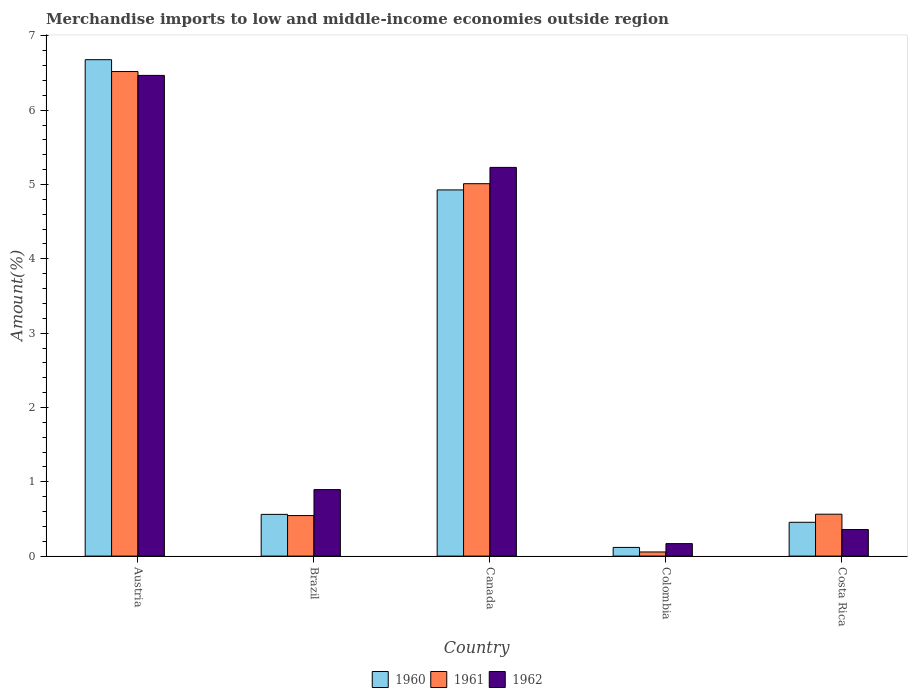How many different coloured bars are there?
Your answer should be very brief. 3. How many groups of bars are there?
Keep it short and to the point. 5. Are the number of bars per tick equal to the number of legend labels?
Provide a succinct answer. Yes. Are the number of bars on each tick of the X-axis equal?
Make the answer very short. Yes. How many bars are there on the 4th tick from the right?
Provide a succinct answer. 3. What is the percentage of amount earned from merchandise imports in 1960 in Costa Rica?
Give a very brief answer. 0.45. Across all countries, what is the maximum percentage of amount earned from merchandise imports in 1962?
Offer a terse response. 6.47. Across all countries, what is the minimum percentage of amount earned from merchandise imports in 1960?
Provide a short and direct response. 0.12. In which country was the percentage of amount earned from merchandise imports in 1962 maximum?
Offer a very short reply. Austria. What is the total percentage of amount earned from merchandise imports in 1961 in the graph?
Provide a short and direct response. 12.7. What is the difference between the percentage of amount earned from merchandise imports in 1962 in Brazil and that in Costa Rica?
Your response must be concise. 0.54. What is the difference between the percentage of amount earned from merchandise imports in 1960 in Colombia and the percentage of amount earned from merchandise imports in 1961 in Austria?
Make the answer very short. -6.4. What is the average percentage of amount earned from merchandise imports in 1960 per country?
Provide a succinct answer. 2.55. What is the difference between the percentage of amount earned from merchandise imports of/in 1961 and percentage of amount earned from merchandise imports of/in 1960 in Costa Rica?
Your response must be concise. 0.11. What is the ratio of the percentage of amount earned from merchandise imports in 1962 in Brazil to that in Costa Rica?
Ensure brevity in your answer.  2.5. What is the difference between the highest and the second highest percentage of amount earned from merchandise imports in 1960?
Provide a succinct answer. -4.37. What is the difference between the highest and the lowest percentage of amount earned from merchandise imports in 1962?
Keep it short and to the point. 6.3. In how many countries, is the percentage of amount earned from merchandise imports in 1960 greater than the average percentage of amount earned from merchandise imports in 1960 taken over all countries?
Your response must be concise. 2. Is the sum of the percentage of amount earned from merchandise imports in 1962 in Brazil and Colombia greater than the maximum percentage of amount earned from merchandise imports in 1961 across all countries?
Ensure brevity in your answer.  No. What does the 3rd bar from the left in Austria represents?
Provide a short and direct response. 1962. What does the 3rd bar from the right in Brazil represents?
Keep it short and to the point. 1960. How many bars are there?
Your response must be concise. 15. How many countries are there in the graph?
Provide a short and direct response. 5. Are the values on the major ticks of Y-axis written in scientific E-notation?
Give a very brief answer. No. Does the graph contain any zero values?
Keep it short and to the point. No. What is the title of the graph?
Your response must be concise. Merchandise imports to low and middle-income economies outside region. Does "2010" appear as one of the legend labels in the graph?
Give a very brief answer. No. What is the label or title of the X-axis?
Ensure brevity in your answer.  Country. What is the label or title of the Y-axis?
Offer a very short reply. Amount(%). What is the Amount(%) in 1960 in Austria?
Offer a very short reply. 6.68. What is the Amount(%) of 1961 in Austria?
Your answer should be compact. 6.52. What is the Amount(%) of 1962 in Austria?
Your response must be concise. 6.47. What is the Amount(%) in 1960 in Brazil?
Make the answer very short. 0.56. What is the Amount(%) of 1961 in Brazil?
Ensure brevity in your answer.  0.55. What is the Amount(%) of 1962 in Brazil?
Give a very brief answer. 0.89. What is the Amount(%) in 1960 in Canada?
Keep it short and to the point. 4.93. What is the Amount(%) in 1961 in Canada?
Offer a terse response. 5.01. What is the Amount(%) of 1962 in Canada?
Your response must be concise. 5.23. What is the Amount(%) in 1960 in Colombia?
Give a very brief answer. 0.12. What is the Amount(%) in 1961 in Colombia?
Ensure brevity in your answer.  0.06. What is the Amount(%) in 1962 in Colombia?
Keep it short and to the point. 0.17. What is the Amount(%) of 1960 in Costa Rica?
Make the answer very short. 0.45. What is the Amount(%) in 1961 in Costa Rica?
Provide a short and direct response. 0.56. What is the Amount(%) of 1962 in Costa Rica?
Your answer should be compact. 0.36. Across all countries, what is the maximum Amount(%) in 1960?
Provide a succinct answer. 6.68. Across all countries, what is the maximum Amount(%) in 1961?
Your answer should be very brief. 6.52. Across all countries, what is the maximum Amount(%) in 1962?
Provide a short and direct response. 6.47. Across all countries, what is the minimum Amount(%) of 1960?
Give a very brief answer. 0.12. Across all countries, what is the minimum Amount(%) in 1961?
Ensure brevity in your answer.  0.06. Across all countries, what is the minimum Amount(%) of 1962?
Provide a short and direct response. 0.17. What is the total Amount(%) of 1960 in the graph?
Offer a very short reply. 12.74. What is the total Amount(%) in 1961 in the graph?
Offer a terse response. 12.7. What is the total Amount(%) in 1962 in the graph?
Provide a short and direct response. 13.12. What is the difference between the Amount(%) of 1960 in Austria and that in Brazil?
Your response must be concise. 6.12. What is the difference between the Amount(%) in 1961 in Austria and that in Brazil?
Your response must be concise. 5.97. What is the difference between the Amount(%) in 1962 in Austria and that in Brazil?
Your answer should be very brief. 5.57. What is the difference between the Amount(%) of 1960 in Austria and that in Canada?
Provide a short and direct response. 1.75. What is the difference between the Amount(%) of 1961 in Austria and that in Canada?
Give a very brief answer. 1.51. What is the difference between the Amount(%) of 1962 in Austria and that in Canada?
Make the answer very short. 1.24. What is the difference between the Amount(%) in 1960 in Austria and that in Colombia?
Offer a very short reply. 6.56. What is the difference between the Amount(%) in 1961 in Austria and that in Colombia?
Ensure brevity in your answer.  6.46. What is the difference between the Amount(%) in 1962 in Austria and that in Colombia?
Keep it short and to the point. 6.3. What is the difference between the Amount(%) of 1960 in Austria and that in Costa Rica?
Provide a short and direct response. 6.22. What is the difference between the Amount(%) in 1961 in Austria and that in Costa Rica?
Provide a succinct answer. 5.96. What is the difference between the Amount(%) of 1962 in Austria and that in Costa Rica?
Offer a terse response. 6.11. What is the difference between the Amount(%) in 1960 in Brazil and that in Canada?
Your response must be concise. -4.37. What is the difference between the Amount(%) in 1961 in Brazil and that in Canada?
Offer a terse response. -4.47. What is the difference between the Amount(%) of 1962 in Brazil and that in Canada?
Ensure brevity in your answer.  -4.34. What is the difference between the Amount(%) in 1960 in Brazil and that in Colombia?
Ensure brevity in your answer.  0.44. What is the difference between the Amount(%) in 1961 in Brazil and that in Colombia?
Provide a succinct answer. 0.49. What is the difference between the Amount(%) in 1962 in Brazil and that in Colombia?
Ensure brevity in your answer.  0.73. What is the difference between the Amount(%) of 1960 in Brazil and that in Costa Rica?
Your answer should be very brief. 0.11. What is the difference between the Amount(%) of 1961 in Brazil and that in Costa Rica?
Your answer should be compact. -0.02. What is the difference between the Amount(%) of 1962 in Brazil and that in Costa Rica?
Make the answer very short. 0.54. What is the difference between the Amount(%) of 1960 in Canada and that in Colombia?
Provide a succinct answer. 4.81. What is the difference between the Amount(%) in 1961 in Canada and that in Colombia?
Make the answer very short. 4.96. What is the difference between the Amount(%) in 1962 in Canada and that in Colombia?
Make the answer very short. 5.06. What is the difference between the Amount(%) in 1960 in Canada and that in Costa Rica?
Provide a short and direct response. 4.47. What is the difference between the Amount(%) of 1961 in Canada and that in Costa Rica?
Your response must be concise. 4.45. What is the difference between the Amount(%) in 1962 in Canada and that in Costa Rica?
Your response must be concise. 4.87. What is the difference between the Amount(%) in 1960 in Colombia and that in Costa Rica?
Make the answer very short. -0.34. What is the difference between the Amount(%) of 1961 in Colombia and that in Costa Rica?
Provide a short and direct response. -0.51. What is the difference between the Amount(%) of 1962 in Colombia and that in Costa Rica?
Ensure brevity in your answer.  -0.19. What is the difference between the Amount(%) of 1960 in Austria and the Amount(%) of 1961 in Brazil?
Your answer should be very brief. 6.13. What is the difference between the Amount(%) of 1960 in Austria and the Amount(%) of 1962 in Brazil?
Your answer should be compact. 5.78. What is the difference between the Amount(%) of 1961 in Austria and the Amount(%) of 1962 in Brazil?
Keep it short and to the point. 5.63. What is the difference between the Amount(%) of 1960 in Austria and the Amount(%) of 1961 in Canada?
Make the answer very short. 1.67. What is the difference between the Amount(%) in 1960 in Austria and the Amount(%) in 1962 in Canada?
Make the answer very short. 1.45. What is the difference between the Amount(%) in 1961 in Austria and the Amount(%) in 1962 in Canada?
Your answer should be very brief. 1.29. What is the difference between the Amount(%) in 1960 in Austria and the Amount(%) in 1961 in Colombia?
Your answer should be very brief. 6.62. What is the difference between the Amount(%) in 1960 in Austria and the Amount(%) in 1962 in Colombia?
Ensure brevity in your answer.  6.51. What is the difference between the Amount(%) in 1961 in Austria and the Amount(%) in 1962 in Colombia?
Offer a terse response. 6.35. What is the difference between the Amount(%) of 1960 in Austria and the Amount(%) of 1961 in Costa Rica?
Your answer should be very brief. 6.12. What is the difference between the Amount(%) in 1960 in Austria and the Amount(%) in 1962 in Costa Rica?
Provide a short and direct response. 6.32. What is the difference between the Amount(%) in 1961 in Austria and the Amount(%) in 1962 in Costa Rica?
Your answer should be very brief. 6.16. What is the difference between the Amount(%) of 1960 in Brazil and the Amount(%) of 1961 in Canada?
Provide a short and direct response. -4.45. What is the difference between the Amount(%) of 1960 in Brazil and the Amount(%) of 1962 in Canada?
Your answer should be compact. -4.67. What is the difference between the Amount(%) of 1961 in Brazil and the Amount(%) of 1962 in Canada?
Offer a terse response. -4.68. What is the difference between the Amount(%) of 1960 in Brazil and the Amount(%) of 1961 in Colombia?
Ensure brevity in your answer.  0.51. What is the difference between the Amount(%) of 1960 in Brazil and the Amount(%) of 1962 in Colombia?
Your response must be concise. 0.39. What is the difference between the Amount(%) of 1961 in Brazil and the Amount(%) of 1962 in Colombia?
Offer a very short reply. 0.38. What is the difference between the Amount(%) in 1960 in Brazil and the Amount(%) in 1961 in Costa Rica?
Offer a very short reply. -0. What is the difference between the Amount(%) in 1960 in Brazil and the Amount(%) in 1962 in Costa Rica?
Offer a very short reply. 0.2. What is the difference between the Amount(%) of 1961 in Brazil and the Amount(%) of 1962 in Costa Rica?
Offer a terse response. 0.19. What is the difference between the Amount(%) of 1960 in Canada and the Amount(%) of 1961 in Colombia?
Keep it short and to the point. 4.87. What is the difference between the Amount(%) of 1960 in Canada and the Amount(%) of 1962 in Colombia?
Your answer should be very brief. 4.76. What is the difference between the Amount(%) in 1961 in Canada and the Amount(%) in 1962 in Colombia?
Keep it short and to the point. 4.84. What is the difference between the Amount(%) in 1960 in Canada and the Amount(%) in 1961 in Costa Rica?
Give a very brief answer. 4.36. What is the difference between the Amount(%) of 1960 in Canada and the Amount(%) of 1962 in Costa Rica?
Provide a short and direct response. 4.57. What is the difference between the Amount(%) of 1961 in Canada and the Amount(%) of 1962 in Costa Rica?
Your answer should be compact. 4.65. What is the difference between the Amount(%) of 1960 in Colombia and the Amount(%) of 1961 in Costa Rica?
Provide a succinct answer. -0.45. What is the difference between the Amount(%) of 1960 in Colombia and the Amount(%) of 1962 in Costa Rica?
Your response must be concise. -0.24. What is the difference between the Amount(%) of 1961 in Colombia and the Amount(%) of 1962 in Costa Rica?
Make the answer very short. -0.3. What is the average Amount(%) of 1960 per country?
Your answer should be compact. 2.55. What is the average Amount(%) in 1961 per country?
Make the answer very short. 2.54. What is the average Amount(%) in 1962 per country?
Give a very brief answer. 2.62. What is the difference between the Amount(%) in 1960 and Amount(%) in 1961 in Austria?
Offer a very short reply. 0.16. What is the difference between the Amount(%) of 1960 and Amount(%) of 1962 in Austria?
Provide a short and direct response. 0.21. What is the difference between the Amount(%) of 1961 and Amount(%) of 1962 in Austria?
Give a very brief answer. 0.05. What is the difference between the Amount(%) in 1960 and Amount(%) in 1961 in Brazil?
Keep it short and to the point. 0.02. What is the difference between the Amount(%) in 1960 and Amount(%) in 1962 in Brazil?
Your response must be concise. -0.33. What is the difference between the Amount(%) in 1961 and Amount(%) in 1962 in Brazil?
Provide a short and direct response. -0.35. What is the difference between the Amount(%) of 1960 and Amount(%) of 1961 in Canada?
Your response must be concise. -0.08. What is the difference between the Amount(%) of 1960 and Amount(%) of 1962 in Canada?
Make the answer very short. -0.3. What is the difference between the Amount(%) of 1961 and Amount(%) of 1962 in Canada?
Ensure brevity in your answer.  -0.22. What is the difference between the Amount(%) in 1960 and Amount(%) in 1961 in Colombia?
Ensure brevity in your answer.  0.06. What is the difference between the Amount(%) in 1960 and Amount(%) in 1962 in Colombia?
Keep it short and to the point. -0.05. What is the difference between the Amount(%) of 1961 and Amount(%) of 1962 in Colombia?
Offer a terse response. -0.11. What is the difference between the Amount(%) in 1960 and Amount(%) in 1961 in Costa Rica?
Offer a very short reply. -0.11. What is the difference between the Amount(%) of 1960 and Amount(%) of 1962 in Costa Rica?
Offer a very short reply. 0.1. What is the difference between the Amount(%) of 1961 and Amount(%) of 1962 in Costa Rica?
Ensure brevity in your answer.  0.21. What is the ratio of the Amount(%) in 1960 in Austria to that in Brazil?
Provide a succinct answer. 11.9. What is the ratio of the Amount(%) of 1961 in Austria to that in Brazil?
Keep it short and to the point. 11.95. What is the ratio of the Amount(%) in 1962 in Austria to that in Brazil?
Provide a short and direct response. 7.23. What is the ratio of the Amount(%) of 1960 in Austria to that in Canada?
Offer a terse response. 1.36. What is the ratio of the Amount(%) of 1961 in Austria to that in Canada?
Provide a short and direct response. 1.3. What is the ratio of the Amount(%) of 1962 in Austria to that in Canada?
Your answer should be compact. 1.24. What is the ratio of the Amount(%) of 1960 in Austria to that in Colombia?
Keep it short and to the point. 57.15. What is the ratio of the Amount(%) of 1961 in Austria to that in Colombia?
Your answer should be very brief. 117.06. What is the ratio of the Amount(%) in 1962 in Austria to that in Colombia?
Give a very brief answer. 38.52. What is the ratio of the Amount(%) in 1960 in Austria to that in Costa Rica?
Ensure brevity in your answer.  14.68. What is the ratio of the Amount(%) in 1961 in Austria to that in Costa Rica?
Keep it short and to the point. 11.56. What is the ratio of the Amount(%) in 1962 in Austria to that in Costa Rica?
Your answer should be compact. 18.09. What is the ratio of the Amount(%) of 1960 in Brazil to that in Canada?
Ensure brevity in your answer.  0.11. What is the ratio of the Amount(%) in 1961 in Brazil to that in Canada?
Provide a succinct answer. 0.11. What is the ratio of the Amount(%) in 1962 in Brazil to that in Canada?
Make the answer very short. 0.17. What is the ratio of the Amount(%) of 1960 in Brazil to that in Colombia?
Provide a short and direct response. 4.8. What is the ratio of the Amount(%) in 1961 in Brazil to that in Colombia?
Give a very brief answer. 9.79. What is the ratio of the Amount(%) in 1962 in Brazil to that in Colombia?
Your answer should be very brief. 5.33. What is the ratio of the Amount(%) of 1960 in Brazil to that in Costa Rica?
Provide a short and direct response. 1.23. What is the ratio of the Amount(%) in 1961 in Brazil to that in Costa Rica?
Provide a short and direct response. 0.97. What is the ratio of the Amount(%) in 1962 in Brazil to that in Costa Rica?
Offer a terse response. 2.5. What is the ratio of the Amount(%) in 1960 in Canada to that in Colombia?
Your answer should be compact. 42.16. What is the ratio of the Amount(%) of 1961 in Canada to that in Colombia?
Keep it short and to the point. 89.96. What is the ratio of the Amount(%) of 1962 in Canada to that in Colombia?
Ensure brevity in your answer.  31.15. What is the ratio of the Amount(%) of 1960 in Canada to that in Costa Rica?
Your answer should be compact. 10.83. What is the ratio of the Amount(%) of 1961 in Canada to that in Costa Rica?
Provide a short and direct response. 8.89. What is the ratio of the Amount(%) of 1962 in Canada to that in Costa Rica?
Keep it short and to the point. 14.63. What is the ratio of the Amount(%) of 1960 in Colombia to that in Costa Rica?
Make the answer very short. 0.26. What is the ratio of the Amount(%) in 1961 in Colombia to that in Costa Rica?
Offer a terse response. 0.1. What is the ratio of the Amount(%) of 1962 in Colombia to that in Costa Rica?
Ensure brevity in your answer.  0.47. What is the difference between the highest and the second highest Amount(%) of 1960?
Offer a very short reply. 1.75. What is the difference between the highest and the second highest Amount(%) of 1961?
Your answer should be compact. 1.51. What is the difference between the highest and the second highest Amount(%) of 1962?
Keep it short and to the point. 1.24. What is the difference between the highest and the lowest Amount(%) in 1960?
Provide a succinct answer. 6.56. What is the difference between the highest and the lowest Amount(%) in 1961?
Offer a terse response. 6.46. What is the difference between the highest and the lowest Amount(%) of 1962?
Your answer should be compact. 6.3. 